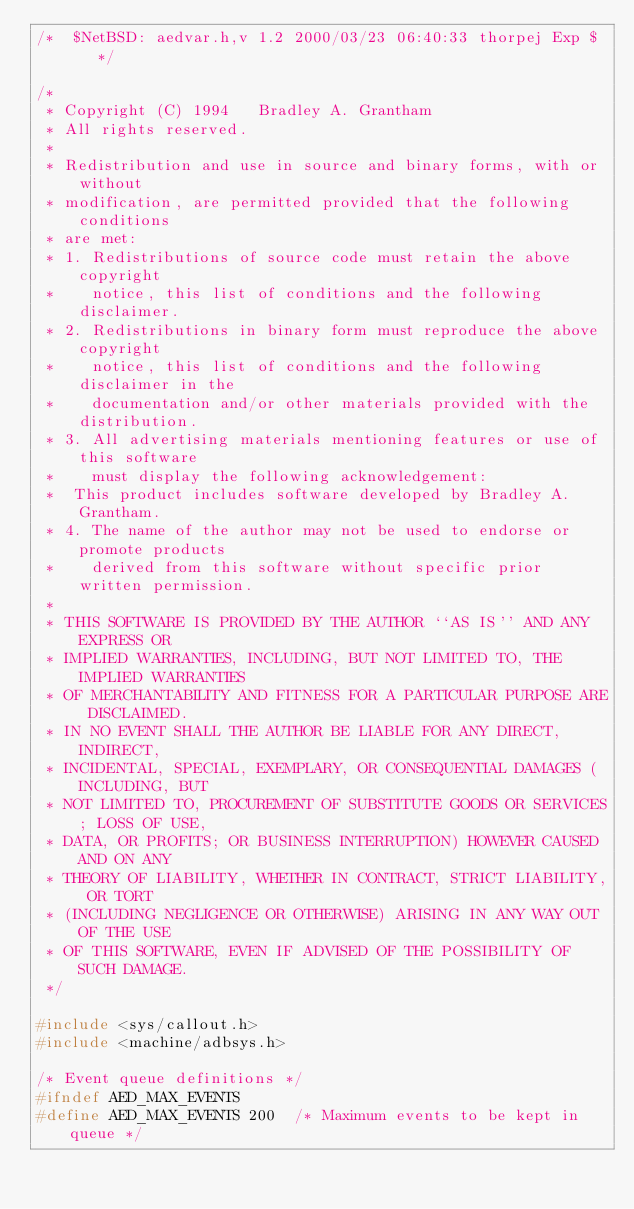<code> <loc_0><loc_0><loc_500><loc_500><_C_>/*	$NetBSD: aedvar.h,v 1.2 2000/03/23 06:40:33 thorpej Exp $	*/

/*
 * Copyright (C) 1994	Bradley A. Grantham
 * All rights reserved.
 *
 * Redistribution and use in source and binary forms, with or without
 * modification, are permitted provided that the following conditions
 * are met:
 * 1. Redistributions of source code must retain the above copyright
 *    notice, this list of conditions and the following disclaimer.
 * 2. Redistributions in binary form must reproduce the above copyright
 *    notice, this list of conditions and the following disclaimer in the
 *    documentation and/or other materials provided with the distribution.
 * 3. All advertising materials mentioning features or use of this software
 *    must display the following acknowledgement:
 *	This product includes software developed by Bradley A. Grantham.
 * 4. The name of the author may not be used to endorse or promote products
 *    derived from this software without specific prior written permission.
 *
 * THIS SOFTWARE IS PROVIDED BY THE AUTHOR ``AS IS'' AND ANY EXPRESS OR
 * IMPLIED WARRANTIES, INCLUDING, BUT NOT LIMITED TO, THE IMPLIED WARRANTIES
 * OF MERCHANTABILITY AND FITNESS FOR A PARTICULAR PURPOSE ARE DISCLAIMED.
 * IN NO EVENT SHALL THE AUTHOR BE LIABLE FOR ANY DIRECT, INDIRECT,
 * INCIDENTAL, SPECIAL, EXEMPLARY, OR CONSEQUENTIAL DAMAGES (INCLUDING, BUT
 * NOT LIMITED TO, PROCUREMENT OF SUBSTITUTE GOODS OR SERVICES; LOSS OF USE,
 * DATA, OR PROFITS; OR BUSINESS INTERRUPTION) HOWEVER CAUSED AND ON ANY
 * THEORY OF LIABILITY, WHETHER IN CONTRACT, STRICT LIABILITY, OR TORT
 * (INCLUDING NEGLIGENCE OR OTHERWISE) ARISING IN ANY WAY OUT OF THE USE
 * OF THIS SOFTWARE, EVEN IF ADVISED OF THE POSSIBILITY OF SUCH DAMAGE.
 */

#include <sys/callout.h>
#include <machine/adbsys.h>

/* Event queue definitions */
#ifndef AED_MAX_EVENTS
#define AED_MAX_EVENTS 200	/* Maximum events to be kept in queue */  </code> 